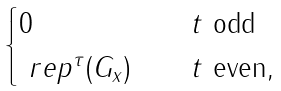<formula> <loc_0><loc_0><loc_500><loc_500>\begin{cases} 0 & \quad t \text { odd} \\ \ r e p ^ { \tau } ( G _ { x } ) & \quad t \text { even} , \end{cases}</formula> 